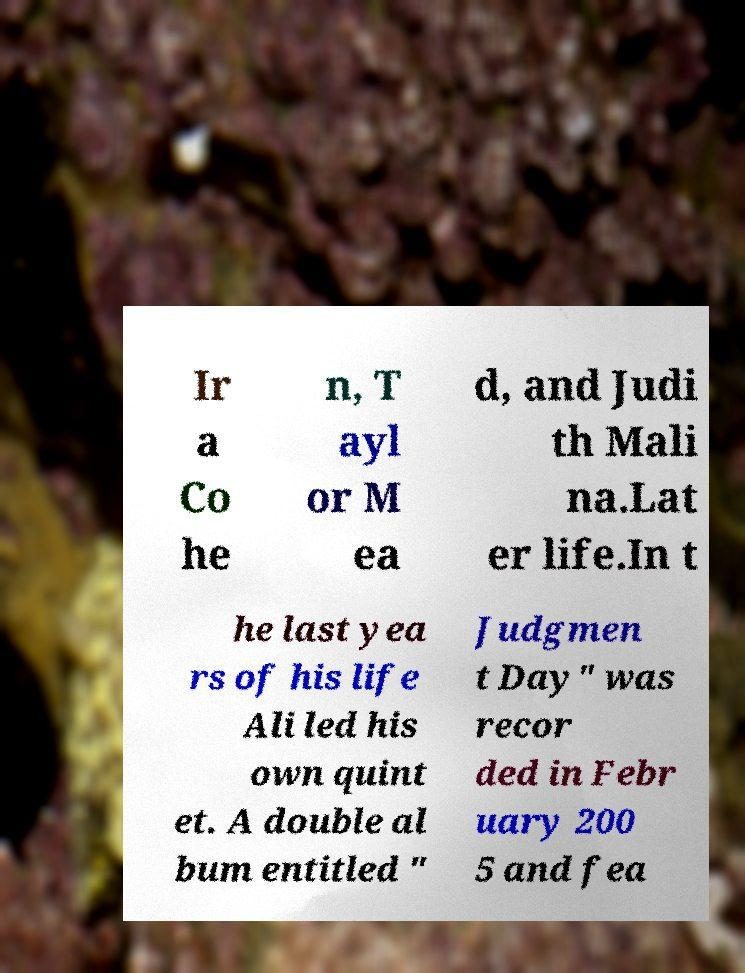Can you accurately transcribe the text from the provided image for me? Ir a Co he n, T ayl or M ea d, and Judi th Mali na.Lat er life.In t he last yea rs of his life Ali led his own quint et. A double al bum entitled " Judgmen t Day" was recor ded in Febr uary 200 5 and fea 